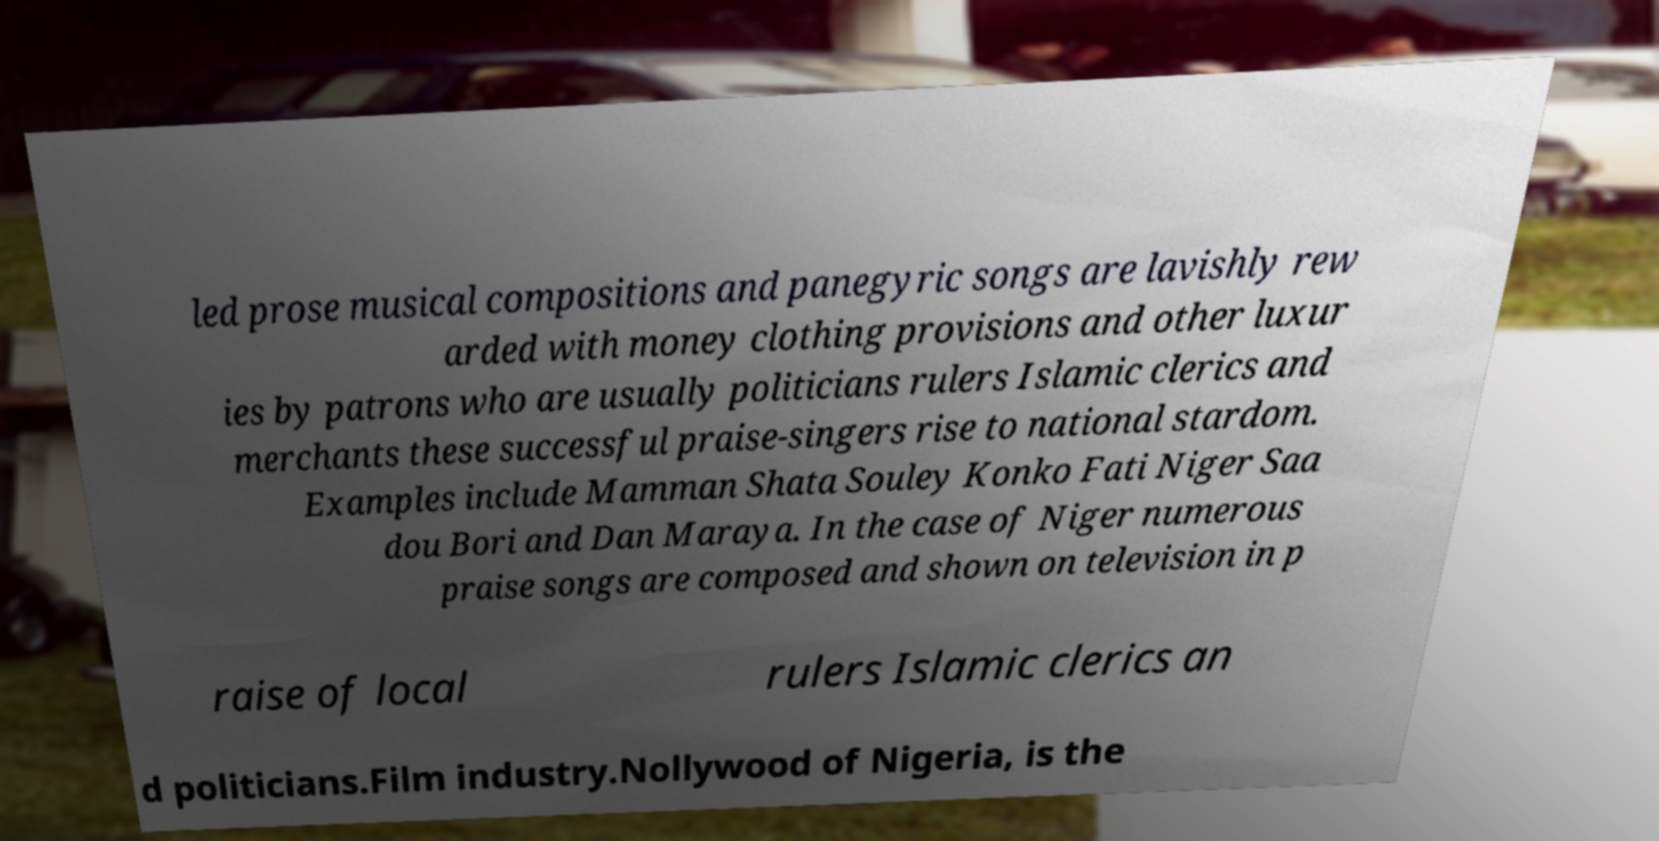Please read and relay the text visible in this image. What does it say? led prose musical compositions and panegyric songs are lavishly rew arded with money clothing provisions and other luxur ies by patrons who are usually politicians rulers Islamic clerics and merchants these successful praise-singers rise to national stardom. Examples include Mamman Shata Souley Konko Fati Niger Saa dou Bori and Dan Maraya. In the case of Niger numerous praise songs are composed and shown on television in p raise of local rulers Islamic clerics an d politicians.Film industry.Nollywood of Nigeria, is the 